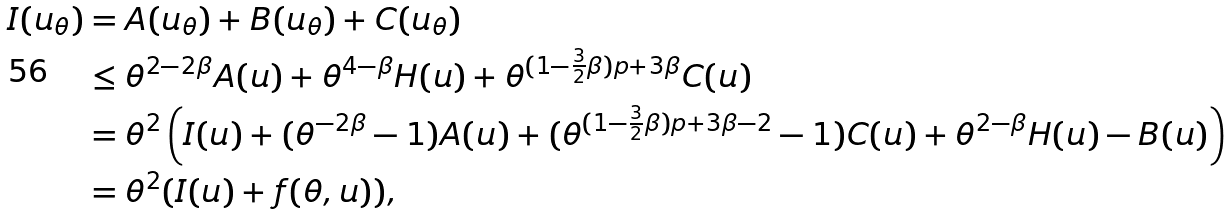<formula> <loc_0><loc_0><loc_500><loc_500>I ( u _ { \theta } ) & = A ( u _ { \theta } ) + B ( u _ { \theta } ) + C ( u _ { \theta } ) \\ & \leq \theta ^ { 2 - 2 \beta } A ( u ) + \theta ^ { 4 - \beta } H ( u ) + \theta ^ { ( 1 - \frac { 3 } { 2 } \beta ) p + 3 \beta } C ( u ) \\ & = \theta ^ { 2 } \left ( I ( u ) + ( \theta ^ { - 2 \beta } - 1 ) A ( u ) + ( \theta ^ { ( 1 - \frac { 3 } { 2 } \beta ) p + 3 \beta - 2 } - 1 ) C ( u ) + \theta ^ { 2 - \beta } H ( u ) - B ( u ) \right ) \\ & = \theta ^ { 2 } ( I ( u ) + f ( \theta , u ) ) ,</formula> 